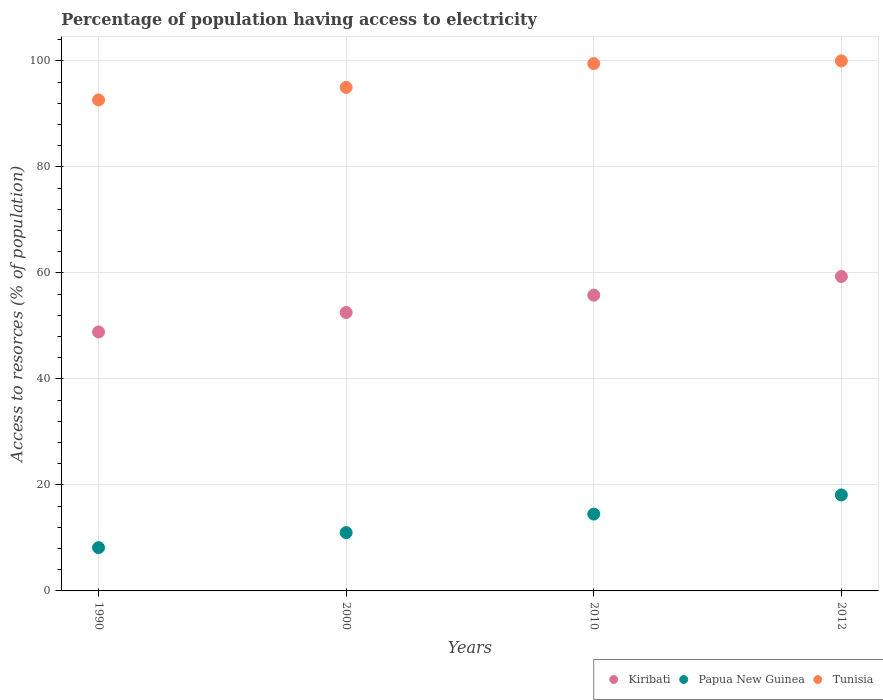How many different coloured dotlines are there?
Your answer should be very brief. 3. What is the percentage of population having access to electricity in Kiribati in 2012?
Keep it short and to the point. 59.33. Across all years, what is the maximum percentage of population having access to electricity in Kiribati?
Offer a very short reply. 59.33. Across all years, what is the minimum percentage of population having access to electricity in Papua New Guinea?
Offer a terse response. 8.16. What is the total percentage of population having access to electricity in Tunisia in the graph?
Provide a short and direct response. 387.14. What is the difference between the percentage of population having access to electricity in Papua New Guinea in 2000 and that in 2010?
Offer a very short reply. -3.5. What is the difference between the percentage of population having access to electricity in Papua New Guinea in 2000 and the percentage of population having access to electricity in Tunisia in 2012?
Offer a very short reply. -89. What is the average percentage of population having access to electricity in Tunisia per year?
Offer a terse response. 96.78. In the year 1990, what is the difference between the percentage of population having access to electricity in Tunisia and percentage of population having access to electricity in Kiribati?
Offer a terse response. 43.78. In how many years, is the percentage of population having access to electricity in Tunisia greater than 72 %?
Give a very brief answer. 4. What is the ratio of the percentage of population having access to electricity in Tunisia in 1990 to that in 2000?
Your answer should be very brief. 0.98. Is the percentage of population having access to electricity in Tunisia in 1990 less than that in 2010?
Your response must be concise. Yes. What is the difference between the highest and the lowest percentage of population having access to electricity in Kiribati?
Keep it short and to the point. 10.47. Is the sum of the percentage of population having access to electricity in Tunisia in 2010 and 2012 greater than the maximum percentage of population having access to electricity in Papua New Guinea across all years?
Keep it short and to the point. Yes. Does the percentage of population having access to electricity in Kiribati monotonically increase over the years?
Your answer should be compact. Yes. How many years are there in the graph?
Offer a very short reply. 4. Are the values on the major ticks of Y-axis written in scientific E-notation?
Make the answer very short. No. Does the graph contain any zero values?
Keep it short and to the point. No. Does the graph contain grids?
Offer a terse response. Yes. Where does the legend appear in the graph?
Offer a terse response. Bottom right. How many legend labels are there?
Provide a short and direct response. 3. How are the legend labels stacked?
Give a very brief answer. Horizontal. What is the title of the graph?
Provide a succinct answer. Percentage of population having access to electricity. Does "Niger" appear as one of the legend labels in the graph?
Keep it short and to the point. No. What is the label or title of the X-axis?
Your response must be concise. Years. What is the label or title of the Y-axis?
Your answer should be very brief. Access to resorces (% of population). What is the Access to resorces (% of population) in Kiribati in 1990?
Offer a very short reply. 48.86. What is the Access to resorces (% of population) of Papua New Guinea in 1990?
Provide a succinct answer. 8.16. What is the Access to resorces (% of population) in Tunisia in 1990?
Your answer should be very brief. 92.64. What is the Access to resorces (% of population) of Kiribati in 2000?
Ensure brevity in your answer.  52.53. What is the Access to resorces (% of population) of Papua New Guinea in 2000?
Make the answer very short. 11. What is the Access to resorces (% of population) in Tunisia in 2000?
Offer a very short reply. 95. What is the Access to resorces (% of population) in Kiribati in 2010?
Make the answer very short. 55.8. What is the Access to resorces (% of population) in Tunisia in 2010?
Your answer should be compact. 99.5. What is the Access to resorces (% of population) in Kiribati in 2012?
Your response must be concise. 59.33. What is the Access to resorces (% of population) in Papua New Guinea in 2012?
Make the answer very short. 18.11. Across all years, what is the maximum Access to resorces (% of population) of Kiribati?
Your answer should be compact. 59.33. Across all years, what is the maximum Access to resorces (% of population) of Papua New Guinea?
Make the answer very short. 18.11. Across all years, what is the maximum Access to resorces (% of population) of Tunisia?
Keep it short and to the point. 100. Across all years, what is the minimum Access to resorces (% of population) of Kiribati?
Your answer should be very brief. 48.86. Across all years, what is the minimum Access to resorces (% of population) of Papua New Guinea?
Make the answer very short. 8.16. Across all years, what is the minimum Access to resorces (% of population) of Tunisia?
Provide a succinct answer. 92.64. What is the total Access to resorces (% of population) in Kiribati in the graph?
Keep it short and to the point. 216.52. What is the total Access to resorces (% of population) in Papua New Guinea in the graph?
Your answer should be compact. 51.77. What is the total Access to resorces (% of population) in Tunisia in the graph?
Your response must be concise. 387.14. What is the difference between the Access to resorces (% of population) in Kiribati in 1990 and that in 2000?
Offer a very short reply. -3.67. What is the difference between the Access to resorces (% of population) of Papua New Guinea in 1990 and that in 2000?
Provide a succinct answer. -2.84. What is the difference between the Access to resorces (% of population) in Tunisia in 1990 and that in 2000?
Give a very brief answer. -2.36. What is the difference between the Access to resorces (% of population) in Kiribati in 1990 and that in 2010?
Make the answer very short. -6.94. What is the difference between the Access to resorces (% of population) in Papua New Guinea in 1990 and that in 2010?
Your answer should be very brief. -6.34. What is the difference between the Access to resorces (% of population) of Tunisia in 1990 and that in 2010?
Your answer should be very brief. -6.86. What is the difference between the Access to resorces (% of population) in Kiribati in 1990 and that in 2012?
Provide a short and direct response. -10.47. What is the difference between the Access to resorces (% of population) of Papua New Guinea in 1990 and that in 2012?
Your response must be concise. -9.95. What is the difference between the Access to resorces (% of population) in Tunisia in 1990 and that in 2012?
Provide a short and direct response. -7.36. What is the difference between the Access to resorces (% of population) of Kiribati in 2000 and that in 2010?
Keep it short and to the point. -3.27. What is the difference between the Access to resorces (% of population) in Kiribati in 2000 and that in 2012?
Make the answer very short. -6.8. What is the difference between the Access to resorces (% of population) of Papua New Guinea in 2000 and that in 2012?
Keep it short and to the point. -7.11. What is the difference between the Access to resorces (% of population) in Tunisia in 2000 and that in 2012?
Offer a very short reply. -5. What is the difference between the Access to resorces (% of population) in Kiribati in 2010 and that in 2012?
Your response must be concise. -3.53. What is the difference between the Access to resorces (% of population) of Papua New Guinea in 2010 and that in 2012?
Keep it short and to the point. -3.61. What is the difference between the Access to resorces (% of population) in Tunisia in 2010 and that in 2012?
Your response must be concise. -0.5. What is the difference between the Access to resorces (% of population) in Kiribati in 1990 and the Access to resorces (% of population) in Papua New Guinea in 2000?
Offer a very short reply. 37.86. What is the difference between the Access to resorces (% of population) of Kiribati in 1990 and the Access to resorces (% of population) of Tunisia in 2000?
Offer a very short reply. -46.14. What is the difference between the Access to resorces (% of population) of Papua New Guinea in 1990 and the Access to resorces (% of population) of Tunisia in 2000?
Provide a short and direct response. -86.84. What is the difference between the Access to resorces (% of population) in Kiribati in 1990 and the Access to resorces (% of population) in Papua New Guinea in 2010?
Your response must be concise. 34.36. What is the difference between the Access to resorces (% of population) in Kiribati in 1990 and the Access to resorces (% of population) in Tunisia in 2010?
Your answer should be compact. -50.64. What is the difference between the Access to resorces (% of population) of Papua New Guinea in 1990 and the Access to resorces (% of population) of Tunisia in 2010?
Provide a succinct answer. -91.34. What is the difference between the Access to resorces (% of population) in Kiribati in 1990 and the Access to resorces (% of population) in Papua New Guinea in 2012?
Your response must be concise. 30.75. What is the difference between the Access to resorces (% of population) in Kiribati in 1990 and the Access to resorces (% of population) in Tunisia in 2012?
Your answer should be compact. -51.14. What is the difference between the Access to resorces (% of population) in Papua New Guinea in 1990 and the Access to resorces (% of population) in Tunisia in 2012?
Make the answer very short. -91.84. What is the difference between the Access to resorces (% of population) in Kiribati in 2000 and the Access to resorces (% of population) in Papua New Guinea in 2010?
Offer a terse response. 38.03. What is the difference between the Access to resorces (% of population) of Kiribati in 2000 and the Access to resorces (% of population) of Tunisia in 2010?
Offer a very short reply. -46.97. What is the difference between the Access to resorces (% of population) in Papua New Guinea in 2000 and the Access to resorces (% of population) in Tunisia in 2010?
Keep it short and to the point. -88.5. What is the difference between the Access to resorces (% of population) of Kiribati in 2000 and the Access to resorces (% of population) of Papua New Guinea in 2012?
Give a very brief answer. 34.42. What is the difference between the Access to resorces (% of population) of Kiribati in 2000 and the Access to resorces (% of population) of Tunisia in 2012?
Give a very brief answer. -47.47. What is the difference between the Access to resorces (% of population) of Papua New Guinea in 2000 and the Access to resorces (% of population) of Tunisia in 2012?
Ensure brevity in your answer.  -89. What is the difference between the Access to resorces (% of population) of Kiribati in 2010 and the Access to resorces (% of population) of Papua New Guinea in 2012?
Make the answer very short. 37.69. What is the difference between the Access to resorces (% of population) of Kiribati in 2010 and the Access to resorces (% of population) of Tunisia in 2012?
Provide a short and direct response. -44.2. What is the difference between the Access to resorces (% of population) in Papua New Guinea in 2010 and the Access to resorces (% of population) in Tunisia in 2012?
Make the answer very short. -85.5. What is the average Access to resorces (% of population) of Kiribati per year?
Your answer should be very brief. 54.13. What is the average Access to resorces (% of population) in Papua New Guinea per year?
Offer a terse response. 12.94. What is the average Access to resorces (% of population) in Tunisia per year?
Offer a very short reply. 96.78. In the year 1990, what is the difference between the Access to resorces (% of population) in Kiribati and Access to resorces (% of population) in Papua New Guinea?
Your response must be concise. 40.7. In the year 1990, what is the difference between the Access to resorces (% of population) of Kiribati and Access to resorces (% of population) of Tunisia?
Keep it short and to the point. -43.78. In the year 1990, what is the difference between the Access to resorces (% of population) in Papua New Guinea and Access to resorces (% of population) in Tunisia?
Offer a very short reply. -84.48. In the year 2000, what is the difference between the Access to resorces (% of population) of Kiribati and Access to resorces (% of population) of Papua New Guinea?
Give a very brief answer. 41.53. In the year 2000, what is the difference between the Access to resorces (% of population) in Kiribati and Access to resorces (% of population) in Tunisia?
Provide a short and direct response. -42.47. In the year 2000, what is the difference between the Access to resorces (% of population) of Papua New Guinea and Access to resorces (% of population) of Tunisia?
Your answer should be very brief. -84. In the year 2010, what is the difference between the Access to resorces (% of population) of Kiribati and Access to resorces (% of population) of Papua New Guinea?
Your answer should be very brief. 41.3. In the year 2010, what is the difference between the Access to resorces (% of population) in Kiribati and Access to resorces (% of population) in Tunisia?
Provide a succinct answer. -43.7. In the year 2010, what is the difference between the Access to resorces (% of population) of Papua New Guinea and Access to resorces (% of population) of Tunisia?
Provide a short and direct response. -85. In the year 2012, what is the difference between the Access to resorces (% of population) of Kiribati and Access to resorces (% of population) of Papua New Guinea?
Provide a succinct answer. 41.22. In the year 2012, what is the difference between the Access to resorces (% of population) of Kiribati and Access to resorces (% of population) of Tunisia?
Offer a very short reply. -40.67. In the year 2012, what is the difference between the Access to resorces (% of population) in Papua New Guinea and Access to resorces (% of population) in Tunisia?
Give a very brief answer. -81.89. What is the ratio of the Access to resorces (% of population) in Kiribati in 1990 to that in 2000?
Keep it short and to the point. 0.93. What is the ratio of the Access to resorces (% of population) in Papua New Guinea in 1990 to that in 2000?
Your response must be concise. 0.74. What is the ratio of the Access to resorces (% of population) of Tunisia in 1990 to that in 2000?
Your response must be concise. 0.98. What is the ratio of the Access to resorces (% of population) of Kiribati in 1990 to that in 2010?
Offer a terse response. 0.88. What is the ratio of the Access to resorces (% of population) in Papua New Guinea in 1990 to that in 2010?
Offer a terse response. 0.56. What is the ratio of the Access to resorces (% of population) of Kiribati in 1990 to that in 2012?
Provide a succinct answer. 0.82. What is the ratio of the Access to resorces (% of population) of Papua New Guinea in 1990 to that in 2012?
Your answer should be compact. 0.45. What is the ratio of the Access to resorces (% of population) of Tunisia in 1990 to that in 2012?
Provide a short and direct response. 0.93. What is the ratio of the Access to resorces (% of population) of Kiribati in 2000 to that in 2010?
Keep it short and to the point. 0.94. What is the ratio of the Access to resorces (% of population) in Papua New Guinea in 2000 to that in 2010?
Your answer should be compact. 0.76. What is the ratio of the Access to resorces (% of population) in Tunisia in 2000 to that in 2010?
Offer a terse response. 0.95. What is the ratio of the Access to resorces (% of population) in Kiribati in 2000 to that in 2012?
Offer a very short reply. 0.89. What is the ratio of the Access to resorces (% of population) of Papua New Guinea in 2000 to that in 2012?
Keep it short and to the point. 0.61. What is the ratio of the Access to resorces (% of population) in Kiribati in 2010 to that in 2012?
Offer a very short reply. 0.94. What is the ratio of the Access to resorces (% of population) in Papua New Guinea in 2010 to that in 2012?
Make the answer very short. 0.8. What is the ratio of the Access to resorces (% of population) in Tunisia in 2010 to that in 2012?
Offer a terse response. 0.99. What is the difference between the highest and the second highest Access to resorces (% of population) of Kiribati?
Offer a terse response. 3.53. What is the difference between the highest and the second highest Access to resorces (% of population) in Papua New Guinea?
Offer a very short reply. 3.61. What is the difference between the highest and the lowest Access to resorces (% of population) of Kiribati?
Your response must be concise. 10.47. What is the difference between the highest and the lowest Access to resorces (% of population) of Papua New Guinea?
Give a very brief answer. 9.95. What is the difference between the highest and the lowest Access to resorces (% of population) in Tunisia?
Give a very brief answer. 7.36. 